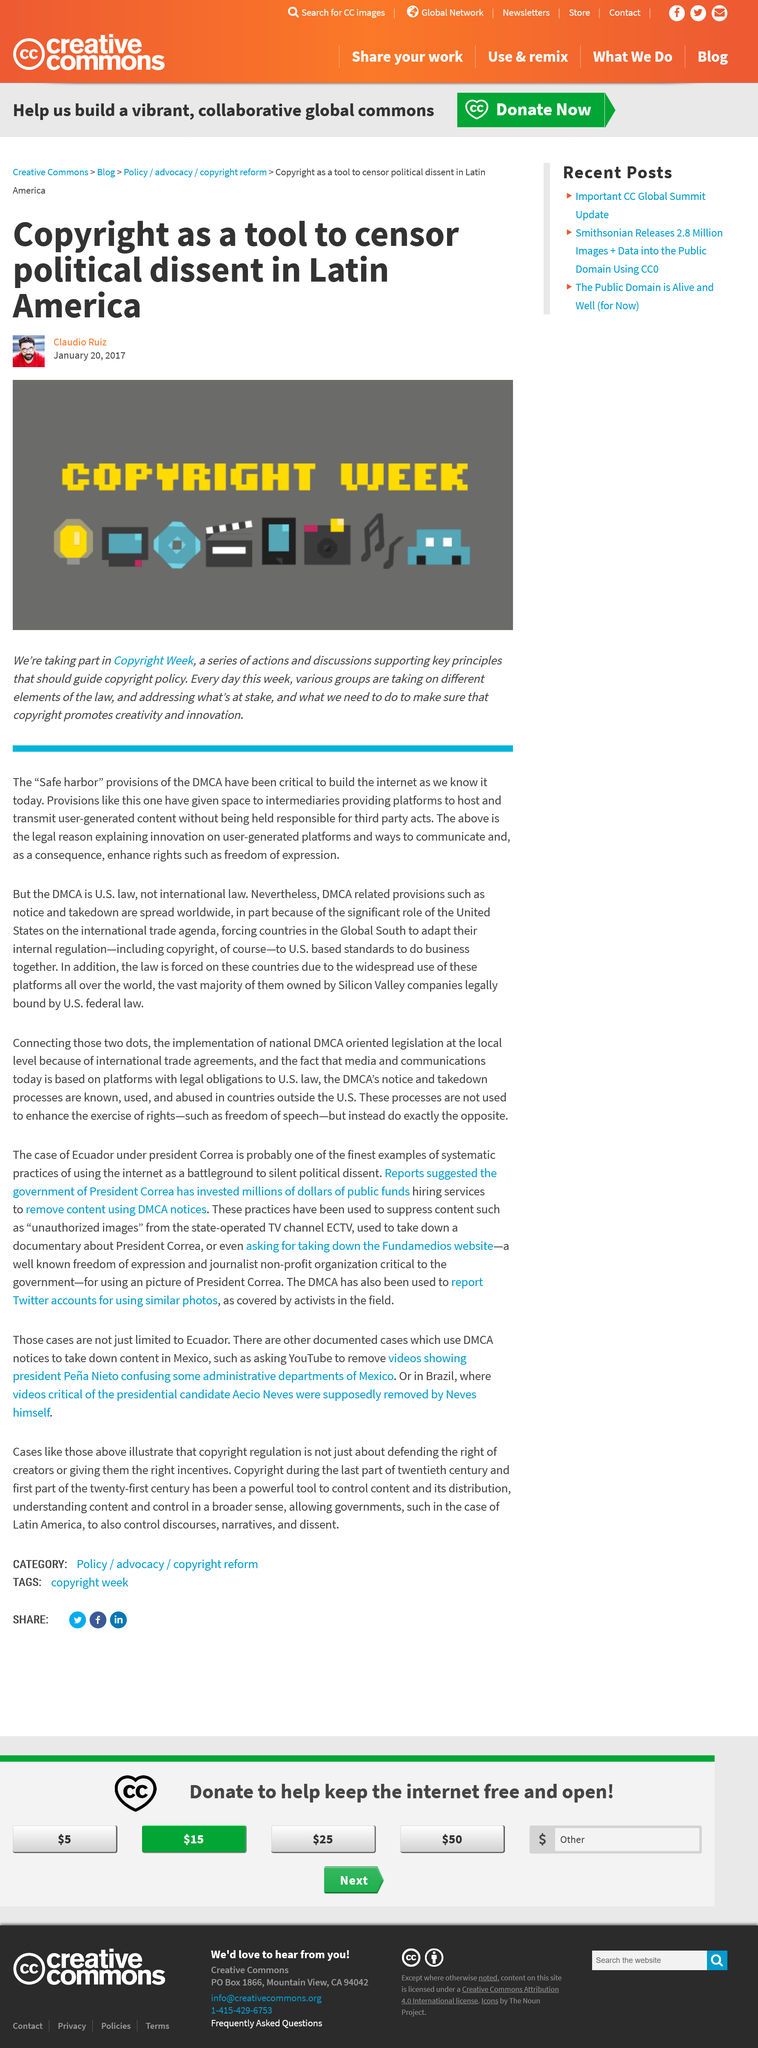Point out several critical features in this image. This was produced on January 20, 2017. In the picture, Claudio Ruiz is wearing a red jumper. I am Claudio Ruiz, the individual responsible for producing this. 